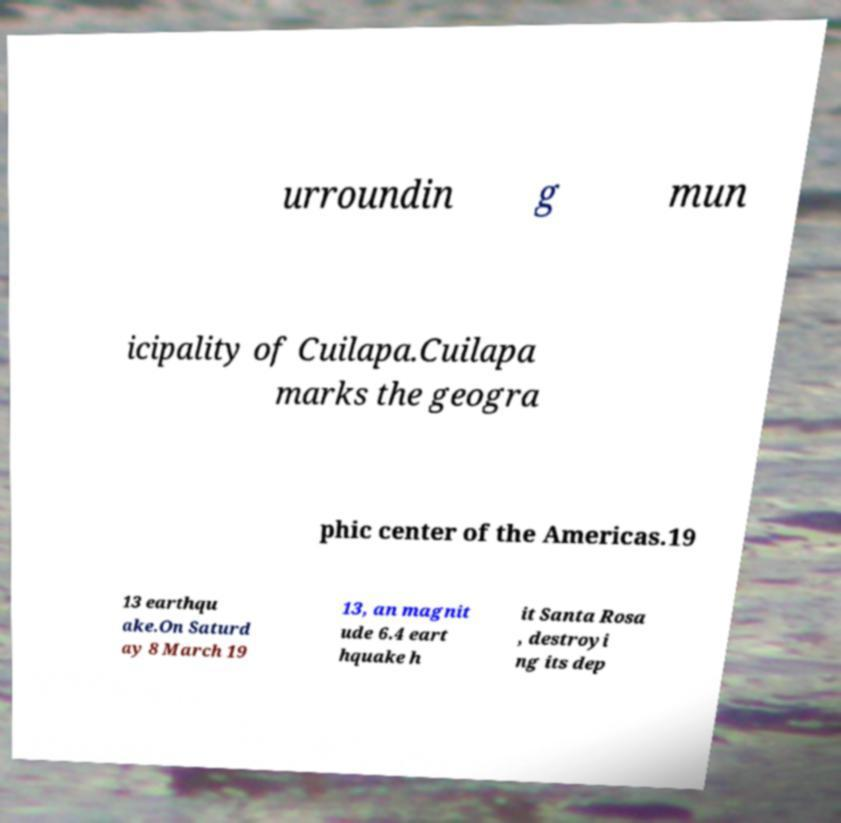Can you accurately transcribe the text from the provided image for me? urroundin g mun icipality of Cuilapa.Cuilapa marks the geogra phic center of the Americas.19 13 earthqu ake.On Saturd ay 8 March 19 13, an magnit ude 6.4 eart hquake h it Santa Rosa , destroyi ng its dep 